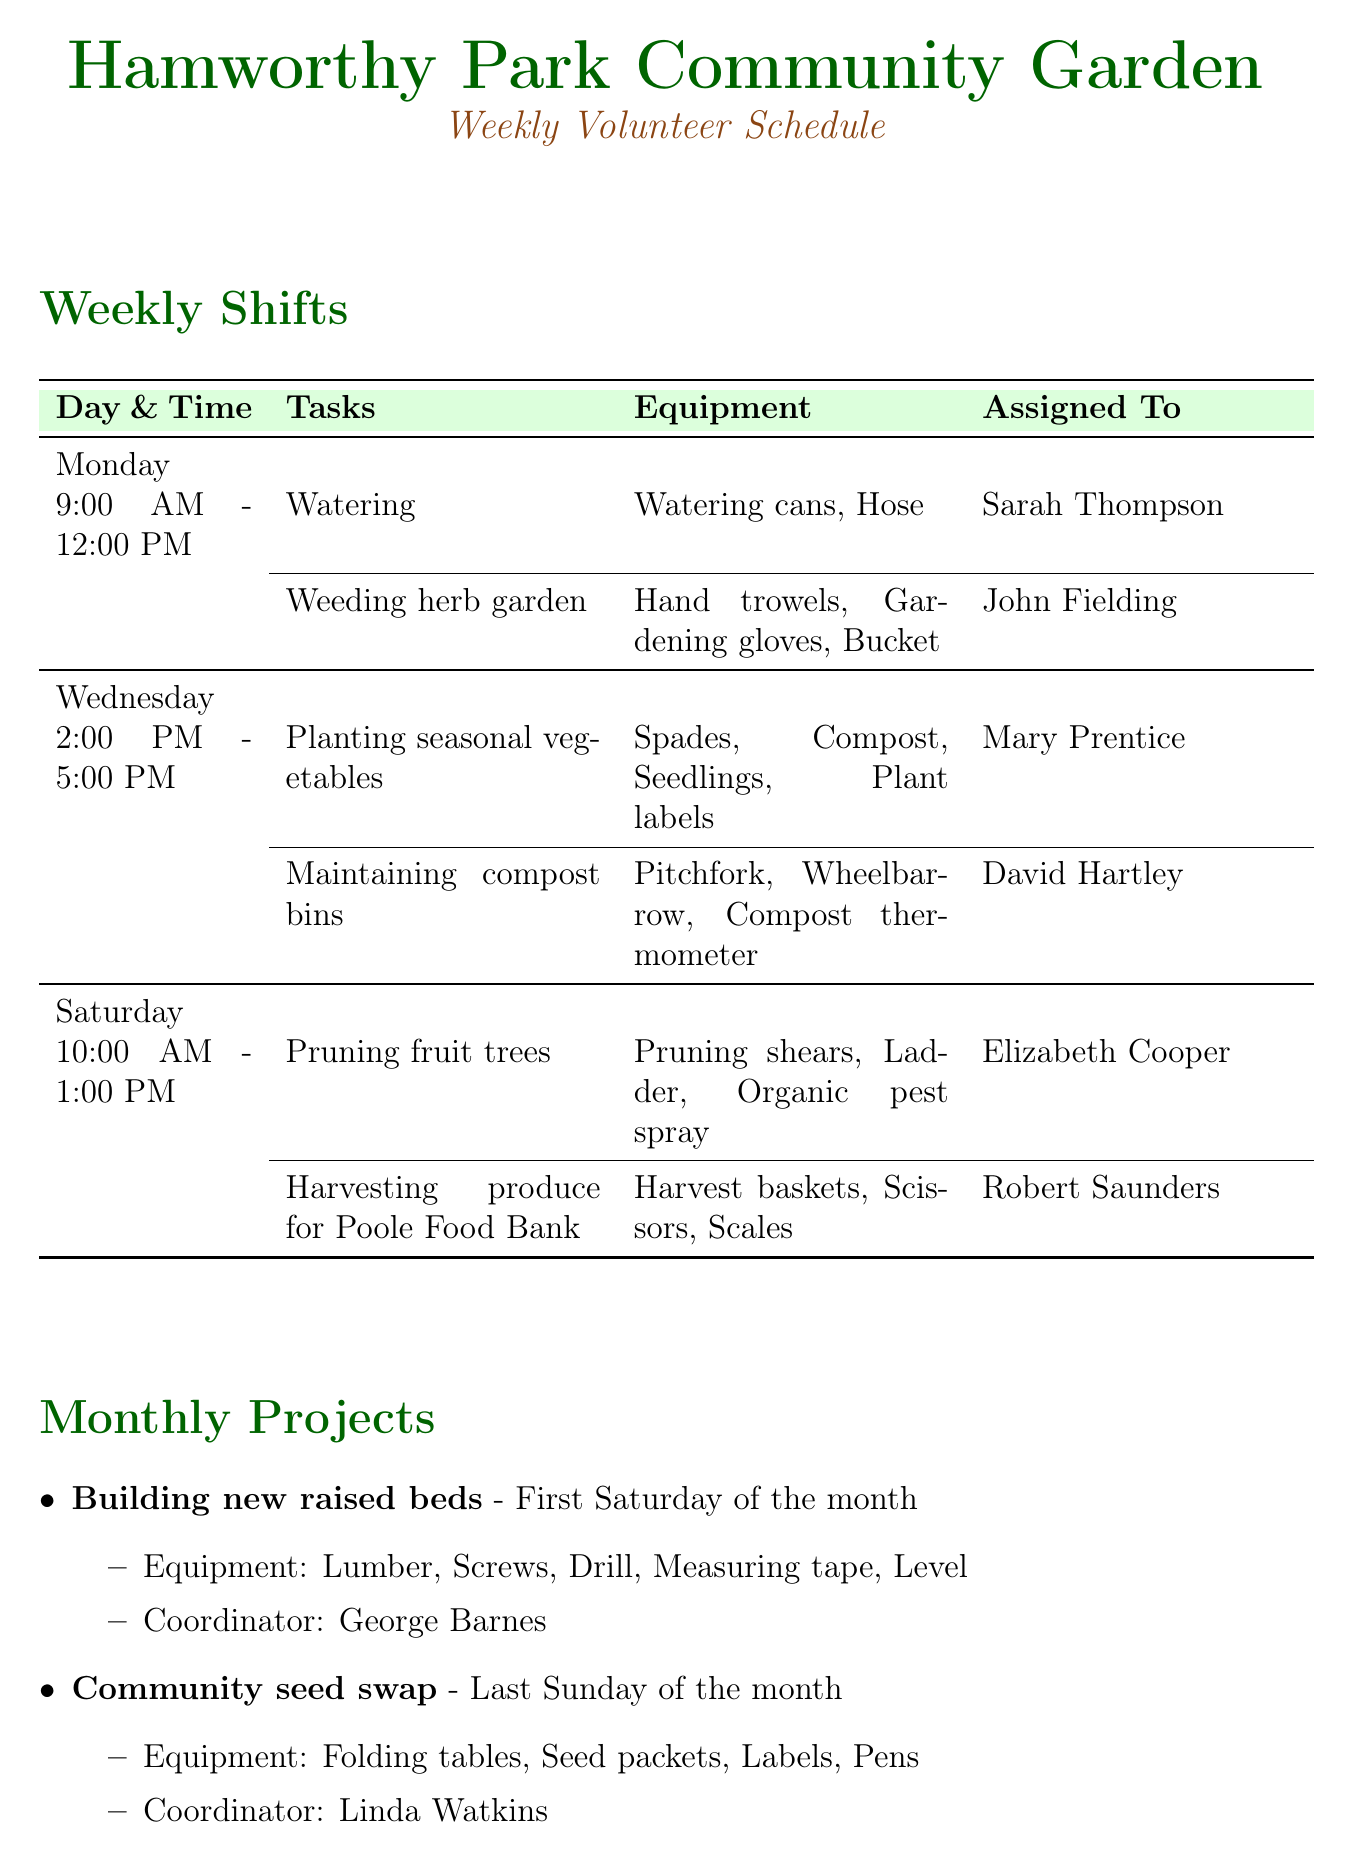What time does the Monday shift start? The Monday shift starts at 9:00 AM according to the schedule.
Answer: 9:00 AM Who is assigned to maintain compost bins on Wednesday? David Hartley is assigned to maintain compost bins as listed in the tasks for Wednesday.
Answer: David Hartley Which project is scheduled for the last Sunday of the month? The project scheduled for the last Sunday of the month is the Community seed swap.
Answer: Community seed swap What equipment is needed for planting seasonal vegetables? The equipment needed for planting seasonal vegetables includes spades, compost, seedlings, and plant labels.
Answer: Spades, Compost, Seedlings, Plant labels Which local partner provides expert advice? The local partner that provides expert advice is the Poole Horticultural Society.
Answer: Poole Horticultural Society How many hours does the Saturday shift last? The Saturday shift lasts for 3 hours, from 10:00 AM to 1:00 PM.
Answer: 3 hours Who is the coordinator for the monthly project on building new raised beds? George Barnes is the coordinator for the project on building new raised beds as stated in the monthly projects section.
Answer: George Barnes What is one feature of the garden? One feature of the garden is wheelchair-accessible paths, mentioned under garden features.
Answer: Wheelchair-accessible paths What task is assigned to Sarah Thompson? Sarah Thompson is assigned to the task of watering according to the Monday schedule.
Answer: Watering 